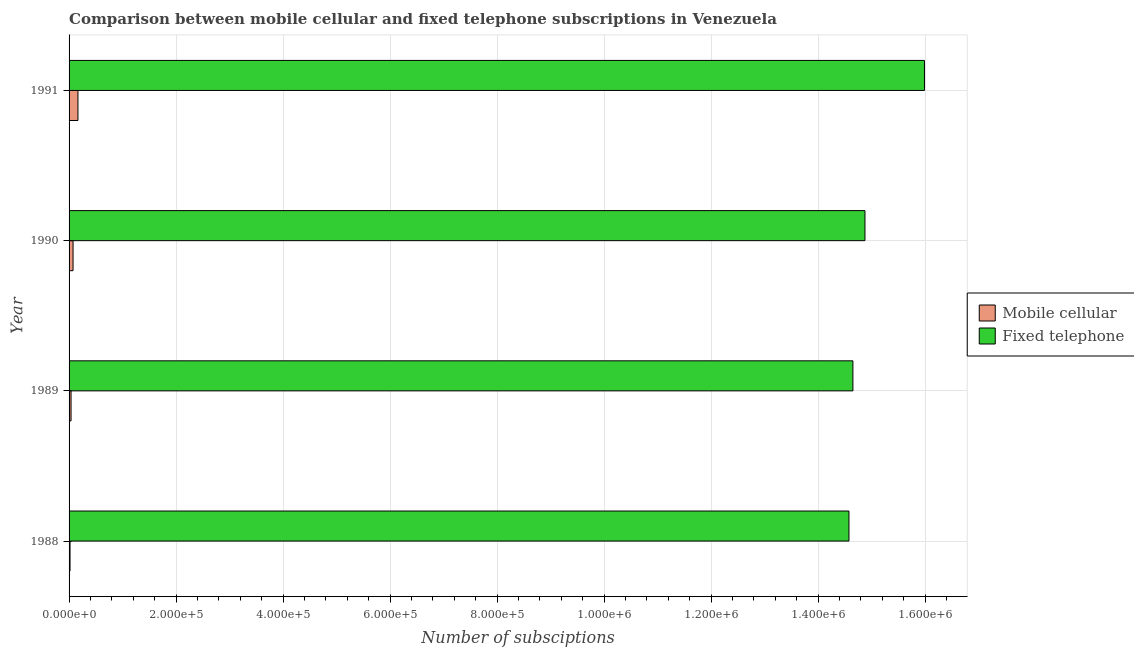How many different coloured bars are there?
Offer a terse response. 2. How many bars are there on the 1st tick from the top?
Provide a succinct answer. 2. What is the label of the 2nd group of bars from the top?
Your response must be concise. 1990. What is the number of fixed telephone subscriptions in 1988?
Provide a succinct answer. 1.46e+06. Across all years, what is the maximum number of mobile cellular subscriptions?
Provide a short and direct response. 1.66e+04. Across all years, what is the minimum number of mobile cellular subscriptions?
Offer a terse response. 1800. What is the total number of mobile cellular subscriptions in the graph?
Your response must be concise. 2.95e+04. What is the difference between the number of fixed telephone subscriptions in 1988 and that in 1989?
Provide a short and direct response. -7398. What is the difference between the number of mobile cellular subscriptions in 1988 and the number of fixed telephone subscriptions in 1991?
Keep it short and to the point. -1.60e+06. What is the average number of mobile cellular subscriptions per year?
Offer a very short reply. 7376.75. In the year 1988, what is the difference between the number of mobile cellular subscriptions and number of fixed telephone subscriptions?
Offer a terse response. -1.46e+06. In how many years, is the number of mobile cellular subscriptions greater than 1200000 ?
Your response must be concise. 0. What is the ratio of the number of mobile cellular subscriptions in 1988 to that in 1990?
Make the answer very short. 0.24. Is the number of fixed telephone subscriptions in 1988 less than that in 1990?
Offer a very short reply. Yes. Is the difference between the number of fixed telephone subscriptions in 1989 and 1990 greater than the difference between the number of mobile cellular subscriptions in 1989 and 1990?
Ensure brevity in your answer.  No. What is the difference between the highest and the second highest number of mobile cellular subscriptions?
Provide a short and direct response. 9178. What is the difference between the highest and the lowest number of mobile cellular subscriptions?
Your answer should be very brief. 1.48e+04. Is the sum of the number of fixed telephone subscriptions in 1989 and 1991 greater than the maximum number of mobile cellular subscriptions across all years?
Your response must be concise. Yes. What does the 2nd bar from the top in 1988 represents?
Provide a short and direct response. Mobile cellular. What does the 1st bar from the bottom in 1988 represents?
Offer a terse response. Mobile cellular. Are all the bars in the graph horizontal?
Provide a short and direct response. Yes. How many years are there in the graph?
Offer a terse response. 4. Does the graph contain grids?
Ensure brevity in your answer.  Yes. Where does the legend appear in the graph?
Keep it short and to the point. Center right. How many legend labels are there?
Your answer should be very brief. 2. What is the title of the graph?
Keep it short and to the point. Comparison between mobile cellular and fixed telephone subscriptions in Venezuela. What is the label or title of the X-axis?
Keep it short and to the point. Number of subsciptions. What is the Number of subsciptions of Mobile cellular in 1988?
Provide a succinct answer. 1800. What is the Number of subsciptions of Fixed telephone in 1988?
Your answer should be very brief. 1.46e+06. What is the Number of subsciptions of Mobile cellular in 1989?
Keep it short and to the point. 3685. What is the Number of subsciptions of Fixed telephone in 1989?
Make the answer very short. 1.47e+06. What is the Number of subsciptions in Mobile cellular in 1990?
Provide a short and direct response. 7422. What is the Number of subsciptions in Fixed telephone in 1990?
Make the answer very short. 1.49e+06. What is the Number of subsciptions in Mobile cellular in 1991?
Your answer should be compact. 1.66e+04. What is the Number of subsciptions of Fixed telephone in 1991?
Offer a very short reply. 1.60e+06. Across all years, what is the maximum Number of subsciptions in Mobile cellular?
Give a very brief answer. 1.66e+04. Across all years, what is the maximum Number of subsciptions in Fixed telephone?
Offer a very short reply. 1.60e+06. Across all years, what is the minimum Number of subsciptions in Mobile cellular?
Your response must be concise. 1800. Across all years, what is the minimum Number of subsciptions of Fixed telephone?
Your answer should be very brief. 1.46e+06. What is the total Number of subsciptions of Mobile cellular in the graph?
Make the answer very short. 2.95e+04. What is the total Number of subsciptions of Fixed telephone in the graph?
Your answer should be very brief. 6.01e+06. What is the difference between the Number of subsciptions in Mobile cellular in 1988 and that in 1989?
Keep it short and to the point. -1885. What is the difference between the Number of subsciptions in Fixed telephone in 1988 and that in 1989?
Provide a succinct answer. -7398. What is the difference between the Number of subsciptions of Mobile cellular in 1988 and that in 1990?
Provide a short and direct response. -5622. What is the difference between the Number of subsciptions in Fixed telephone in 1988 and that in 1990?
Make the answer very short. -2.99e+04. What is the difference between the Number of subsciptions in Mobile cellular in 1988 and that in 1991?
Provide a succinct answer. -1.48e+04. What is the difference between the Number of subsciptions of Fixed telephone in 1988 and that in 1991?
Your answer should be compact. -1.41e+05. What is the difference between the Number of subsciptions in Mobile cellular in 1989 and that in 1990?
Offer a very short reply. -3737. What is the difference between the Number of subsciptions in Fixed telephone in 1989 and that in 1990?
Your answer should be compact. -2.25e+04. What is the difference between the Number of subsciptions in Mobile cellular in 1989 and that in 1991?
Make the answer very short. -1.29e+04. What is the difference between the Number of subsciptions in Fixed telephone in 1989 and that in 1991?
Keep it short and to the point. -1.34e+05. What is the difference between the Number of subsciptions in Mobile cellular in 1990 and that in 1991?
Make the answer very short. -9178. What is the difference between the Number of subsciptions in Fixed telephone in 1990 and that in 1991?
Offer a terse response. -1.11e+05. What is the difference between the Number of subsciptions of Mobile cellular in 1988 and the Number of subsciptions of Fixed telephone in 1989?
Give a very brief answer. -1.46e+06. What is the difference between the Number of subsciptions in Mobile cellular in 1988 and the Number of subsciptions in Fixed telephone in 1990?
Keep it short and to the point. -1.49e+06. What is the difference between the Number of subsciptions in Mobile cellular in 1988 and the Number of subsciptions in Fixed telephone in 1991?
Offer a terse response. -1.60e+06. What is the difference between the Number of subsciptions in Mobile cellular in 1989 and the Number of subsciptions in Fixed telephone in 1990?
Provide a short and direct response. -1.48e+06. What is the difference between the Number of subsciptions in Mobile cellular in 1989 and the Number of subsciptions in Fixed telephone in 1991?
Offer a terse response. -1.60e+06. What is the difference between the Number of subsciptions of Mobile cellular in 1990 and the Number of subsciptions of Fixed telephone in 1991?
Your answer should be compact. -1.59e+06. What is the average Number of subsciptions of Mobile cellular per year?
Provide a short and direct response. 7376.75. What is the average Number of subsciptions in Fixed telephone per year?
Ensure brevity in your answer.  1.50e+06. In the year 1988, what is the difference between the Number of subsciptions of Mobile cellular and Number of subsciptions of Fixed telephone?
Offer a terse response. -1.46e+06. In the year 1989, what is the difference between the Number of subsciptions of Mobile cellular and Number of subsciptions of Fixed telephone?
Offer a terse response. -1.46e+06. In the year 1990, what is the difference between the Number of subsciptions of Mobile cellular and Number of subsciptions of Fixed telephone?
Your answer should be very brief. -1.48e+06. In the year 1991, what is the difference between the Number of subsciptions in Mobile cellular and Number of subsciptions in Fixed telephone?
Your answer should be very brief. -1.58e+06. What is the ratio of the Number of subsciptions in Mobile cellular in 1988 to that in 1989?
Provide a succinct answer. 0.49. What is the ratio of the Number of subsciptions in Mobile cellular in 1988 to that in 1990?
Give a very brief answer. 0.24. What is the ratio of the Number of subsciptions in Fixed telephone in 1988 to that in 1990?
Give a very brief answer. 0.98. What is the ratio of the Number of subsciptions in Mobile cellular in 1988 to that in 1991?
Offer a very short reply. 0.11. What is the ratio of the Number of subsciptions of Fixed telephone in 1988 to that in 1991?
Offer a very short reply. 0.91. What is the ratio of the Number of subsciptions in Mobile cellular in 1989 to that in 1990?
Provide a succinct answer. 0.5. What is the ratio of the Number of subsciptions of Fixed telephone in 1989 to that in 1990?
Offer a very short reply. 0.98. What is the ratio of the Number of subsciptions in Mobile cellular in 1989 to that in 1991?
Your answer should be very brief. 0.22. What is the ratio of the Number of subsciptions of Fixed telephone in 1989 to that in 1991?
Offer a terse response. 0.92. What is the ratio of the Number of subsciptions of Mobile cellular in 1990 to that in 1991?
Offer a very short reply. 0.45. What is the ratio of the Number of subsciptions in Fixed telephone in 1990 to that in 1991?
Your response must be concise. 0.93. What is the difference between the highest and the second highest Number of subsciptions in Mobile cellular?
Ensure brevity in your answer.  9178. What is the difference between the highest and the second highest Number of subsciptions in Fixed telephone?
Keep it short and to the point. 1.11e+05. What is the difference between the highest and the lowest Number of subsciptions in Mobile cellular?
Offer a very short reply. 1.48e+04. What is the difference between the highest and the lowest Number of subsciptions of Fixed telephone?
Give a very brief answer. 1.41e+05. 